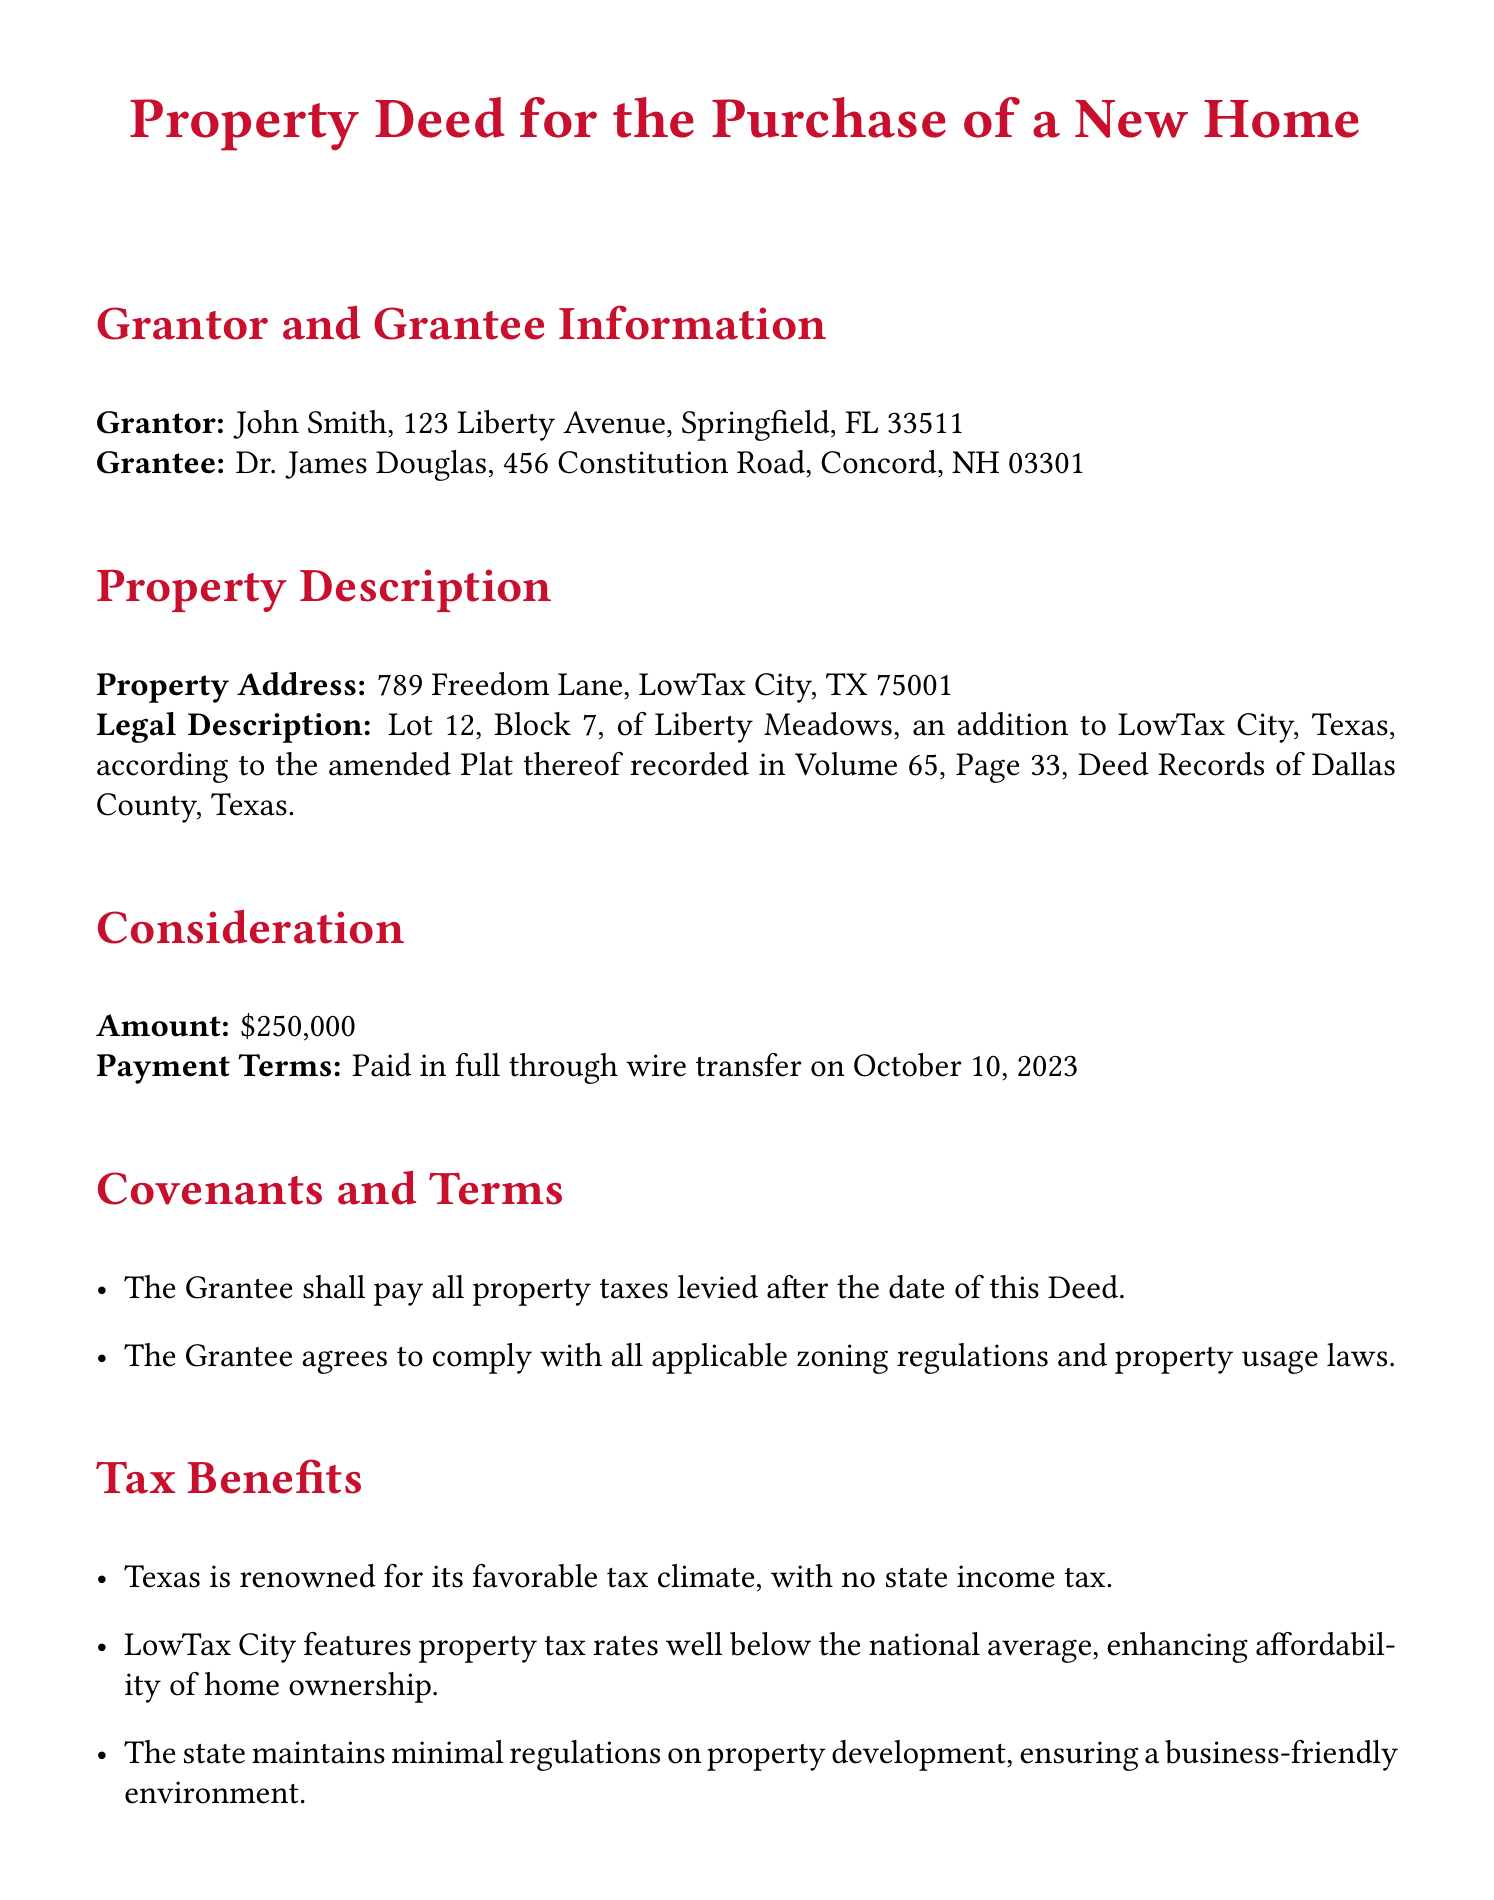What is the name of the Grantor? The Grantor is named as John Smith in the document.
Answer: John Smith What is the property address? The property address is stated in the "Property Description" section of the document.
Answer: 789 Freedom Lane, LowTax City, TX 75001 What is the consideration amount? The consideration amount is mentioned explicitly under the "Consideration" section of the document.
Answer: $250,000 On what date was the payment made? The date of the payment is specified in the "Consideration" section.
Answer: October 10, 2023 What is the name of the Grantee? The Grantee's name is given at the beginning of the document under "Grantor and Grantee Information."
Answer: Dr. James Douglas What taxes must the Grantee pay? The document states that the Grantee shall pay property taxes levied after the date of this Deed.
Answer: Property taxes What is the legal description of the property? The legal description is provided under the "Property Description" section for identification purposes.
Answer: Lot 12, Block 7, of Liberty Meadows, an addition to LowTax City, Texas What notable tax benefit does Texas have? The document highlights that Texas has no state income tax as a tax benefit.
Answer: No state income tax What ensures the Grantee complies with regulations? The Grantee agrees to comply with zoning regulations and property usage laws as stated in the document.
Answer: Compliance agreement 